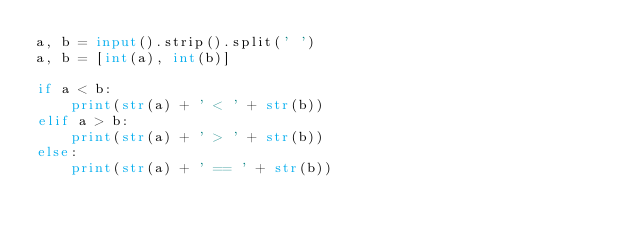Convert code to text. <code><loc_0><loc_0><loc_500><loc_500><_Python_>a, b = input().strip().split(' ')
a, b = [int(a), int(b)]

if a < b:
    print(str(a) + ' < ' + str(b))
elif a > b:
    print(str(a) + ' > ' + str(b))
else:
    print(str(a) + ' == ' + str(b))

</code> 